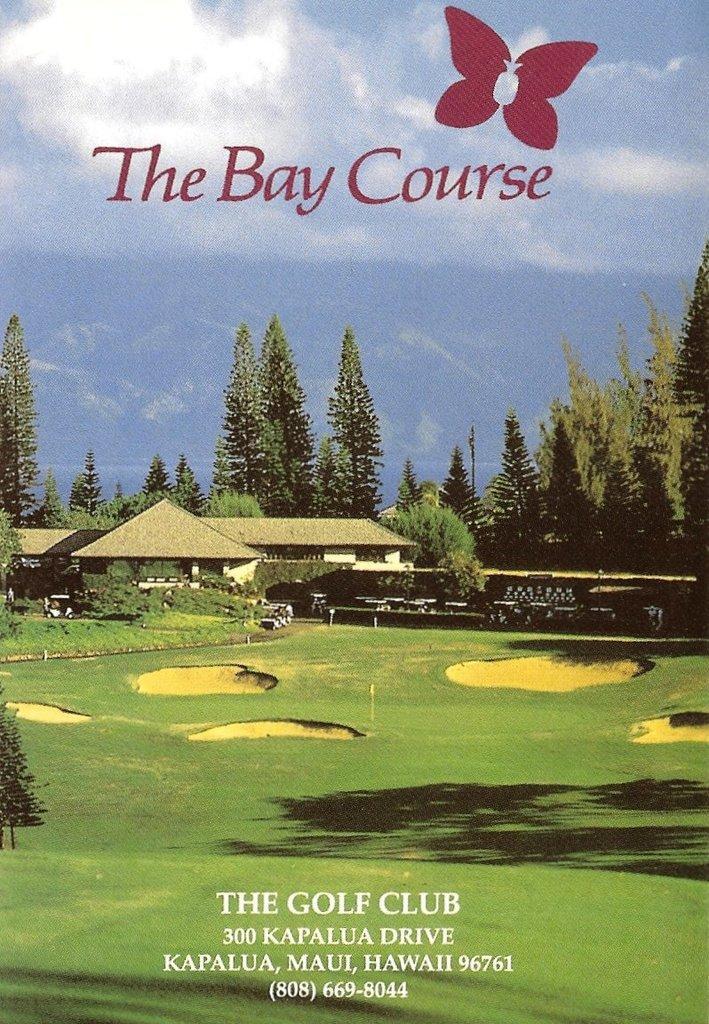<image>
Provide a brief description of the given image. A magazine from The Bay Course golf club. 